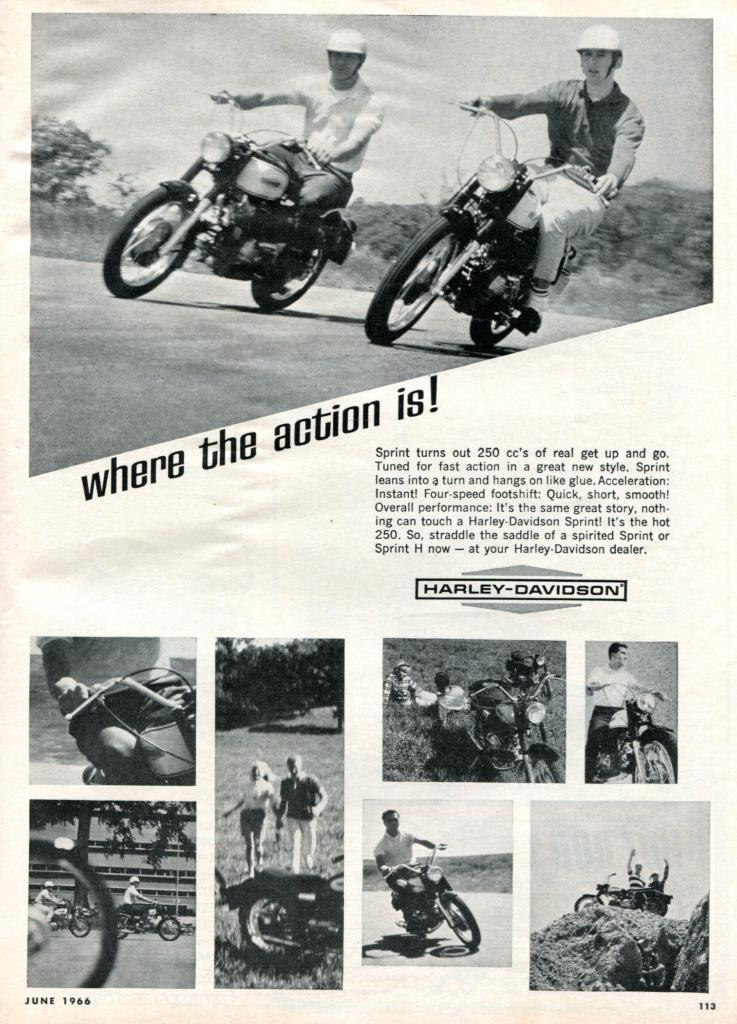What type of page is shown in the image? The image is a cover page. What activity are some of the men engaged in? There are men riding a bike in the image. What other activity can be seen in the image? There are men walking in the image. What scientific process is being demonstrated in the image? There is no scientific process being demonstrated in the image; it shows men riding a bike and walking. 